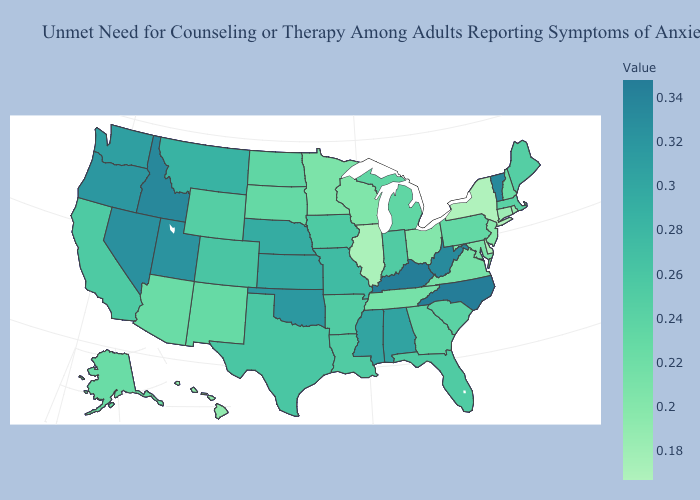Does New Hampshire have the highest value in the Northeast?
Be succinct. No. Does Vermont have the highest value in the Northeast?
Keep it brief. Yes. Does Utah have the lowest value in the West?
Write a very short answer. No. Among the states that border Washington , which have the highest value?
Give a very brief answer. Idaho. Which states have the highest value in the USA?
Concise answer only. North Carolina. Among the states that border Georgia , which have the highest value?
Keep it brief. North Carolina. 